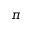Convert formula to latex. <formula><loc_0><loc_0><loc_500><loc_500>\pi</formula> 